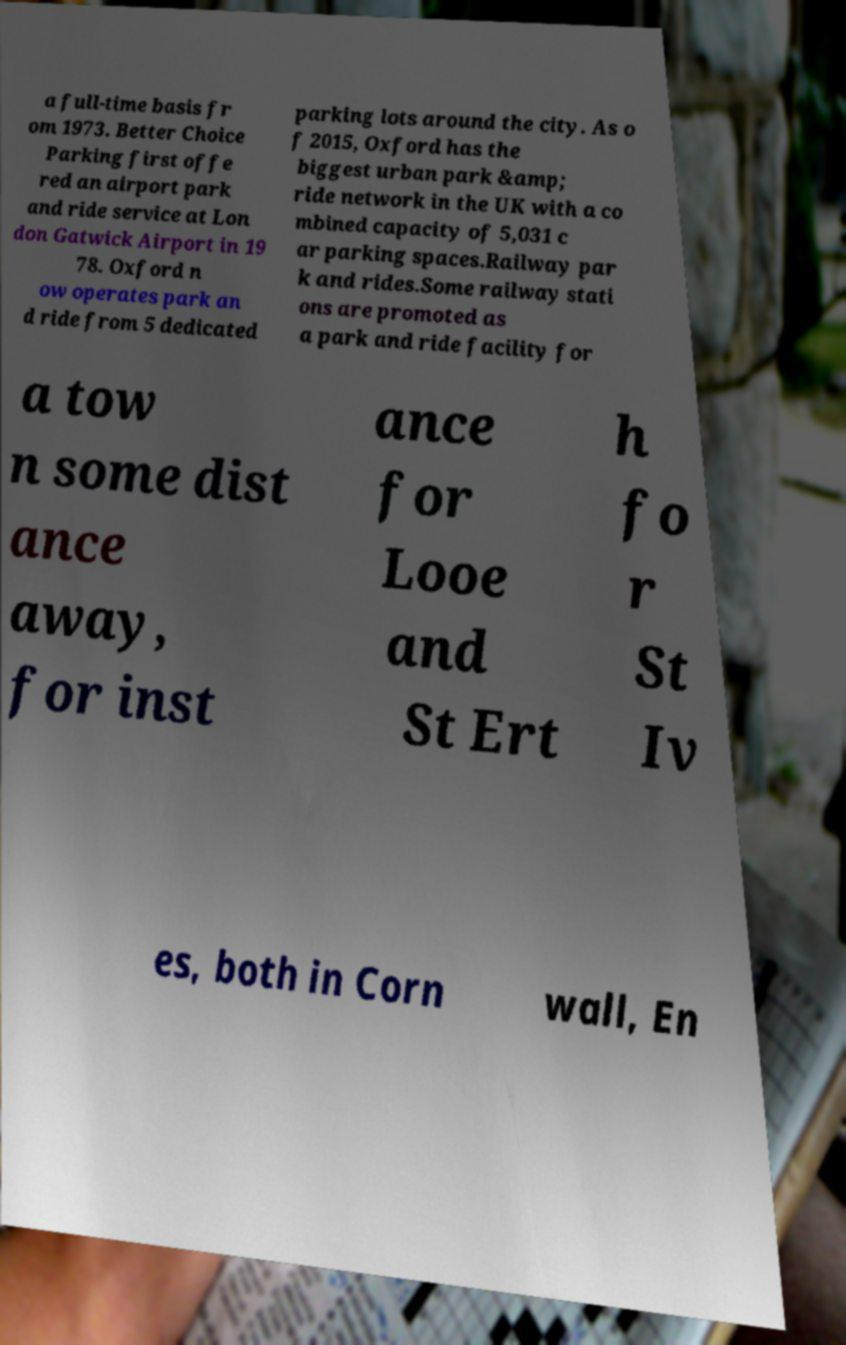Can you accurately transcribe the text from the provided image for me? a full-time basis fr om 1973. Better Choice Parking first offe red an airport park and ride service at Lon don Gatwick Airport in 19 78. Oxford n ow operates park an d ride from 5 dedicated parking lots around the city. As o f 2015, Oxford has the biggest urban park &amp; ride network in the UK with a co mbined capacity of 5,031 c ar parking spaces.Railway par k and rides.Some railway stati ons are promoted as a park and ride facility for a tow n some dist ance away, for inst ance for Looe and St Ert h fo r St Iv es, both in Corn wall, En 